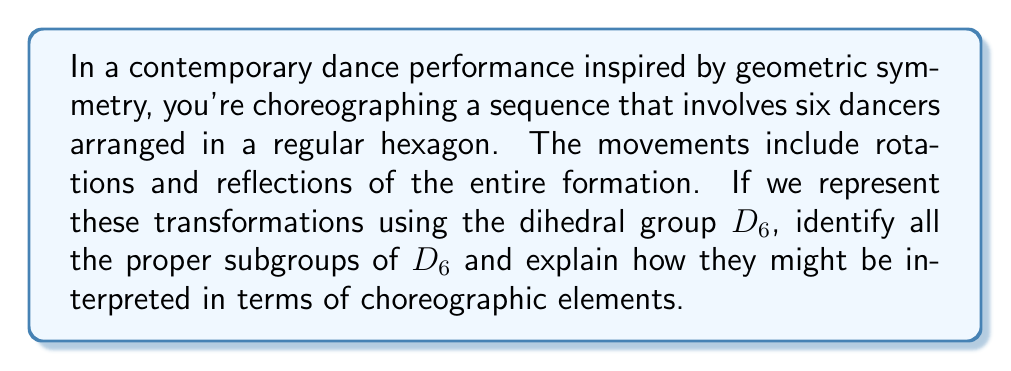Teach me how to tackle this problem. Let's approach this step-by-step:

1) First, recall that the dihedral group $D_6$ has order 12 and is generated by a rotation $r$ of order 6 and a reflection $s$ of order 2.

2) The elements of $D_6$ are: $\{e, r, r^2, r^3, r^4, r^5, s, sr, sr^2, sr^3, sr^4, sr^5\}$

3) To find all subgroups, we need to consider divisors of the group order (12). The possible orders of subgroups are 1, 2, 3, 4, and 6.

4) Subgroups of $D_6$:

   a) Trivial subgroup: $\{e\}$ (order 1)
   
   b) Cyclic subgroups generated by rotations:
      - $\langle r \rangle = \{e, r, r^2, r^3, r^4, r^5\}$ (order 6)
      - $\langle r^2 \rangle = \{e, r^2, r^4\}$ (order 3)
      - $\langle r^3 \rangle = \{e, r^3\}$ (order 2)
   
   c) Subgroups generated by reflections:
      - $\langle s \rangle = \{e, s\}$ (order 2)
      - $\langle sr \rangle = \{e, sr\}$ (order 2)
      - $\langle sr^2 \rangle = \{e, sr^2\}$ (order 2)
      - $\langle sr^3 \rangle = \{e, sr^3\}$ (order 2)
      - $\langle sr^4 \rangle = \{e, sr^4\}$ (order 2)
      - $\langle sr^5 \rangle = \{e, sr^5\}$ (order 2)
   
   d) Dihedral subgroups:
      - $\langle r^2, s \rangle = \{e, r^2, r^4, s, sr^2, sr^4\}$ (order 6)
      - $\langle r^3, s \rangle = \{e, r^3, s, sr^3\}$ (order 4)

5) Choreographic interpretation:
   - The cyclic subgroups represent pure rotations of the formation.
   - The reflection subgroups represent flips across different axes of symmetry.
   - The dihedral subgroups combine both rotations and reflections.
   - Larger subgroups allow for more complex sequences of movements.

6) For example, $\langle r^2 \rangle$ could represent a sequence where the formation rotates by 120° increments, while $\langle r^3, s \rangle$ could represent a sequence alternating between 180° rotations and a specific reflection.
Answer: The proper subgroups of $D_6$ are:

1) $\{e\}$ (order 1)
2) $\langle r \rangle = \{e, r, r^2, r^3, r^4, r^5\}$ (order 6)
3) $\langle r^2 \rangle = \{e, r^2, r^4\}$ (order 3)
4) $\langle r^3 \rangle = \{e, r^3\}$ (order 2)
5) $\langle s \rangle = \{e, s\}$ (order 2)
6) $\langle sr \rangle = \{e, sr\}$ (order 2)
7) $\langle sr^2 \rangle = \{e, sr^2\}$ (order 2)
8) $\langle sr^3 \rangle = \{e, sr^3\}$ (order 2)
9) $\langle sr^4 \rangle = \{e, sr^4\}$ (order 2)
10) $\langle sr^5 \rangle = \{e, sr^5\}$ (order 2)
11) $\langle r^2, s \rangle = \{e, r^2, r^4, s, sr^2, sr^4\}$ (order 6)
12) $\langle r^3, s \rangle = \{e, r^3, s, sr^3\}$ (order 4)

Each subgroup represents a specific set of symmetry operations that can be interpreted as choreographic elements in the dance performance. 